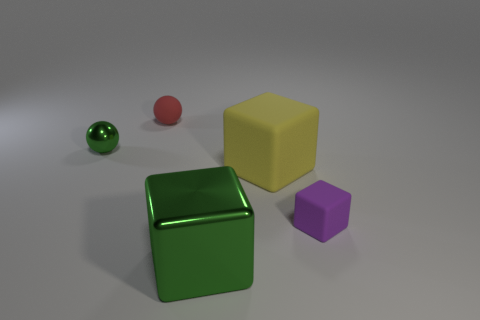Are there any indications of size or scale for the objects? Without everyday objects for comparison, it's difficult to ascertain the precise sizes. However, relative to each other, we can infer the green sphere is the smallest object, followed by the purple cube, the yellow cube, and the green cube which appears the largest. Could you estimate their sizes if we imagine the green sphere as a standard marble? If we imagine the green sphere as a standard marble, which is typically around 1/2 inch in diameter, then the purple cube might be roughly 1 inch across, the yellow cube approximately 1.5 inches, and the green cube could be around 2 inches, given the relative proportions. 